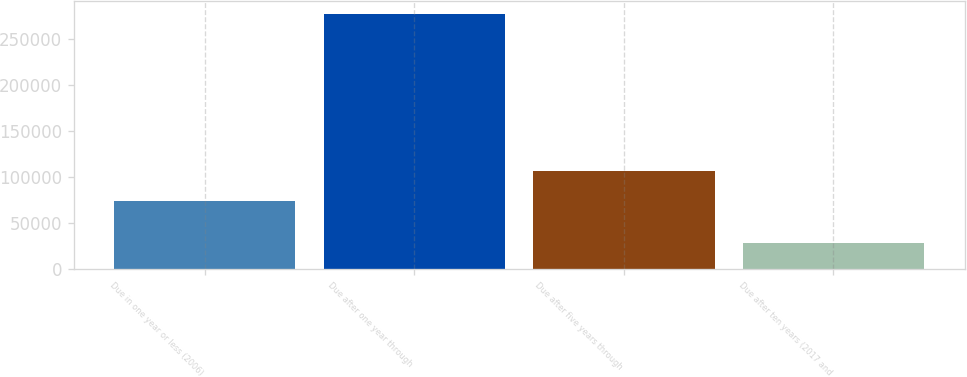Convert chart to OTSL. <chart><loc_0><loc_0><loc_500><loc_500><bar_chart><fcel>Due in one year or less (2006)<fcel>Due after one year through<fcel>Due after five years through<fcel>Due after ten years (2017 and<nl><fcel>73398<fcel>277510<fcel>106917<fcel>27785<nl></chart> 